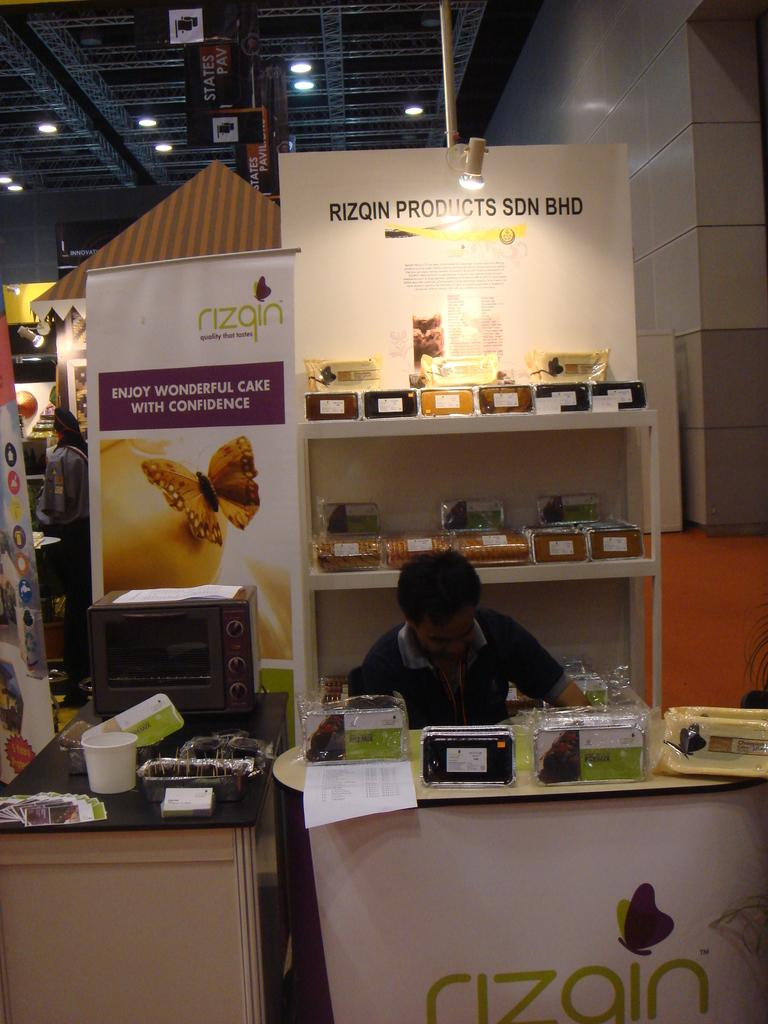<image>
Write a terse but informative summary of the picture. A man sits at a booth for rizqin products. 